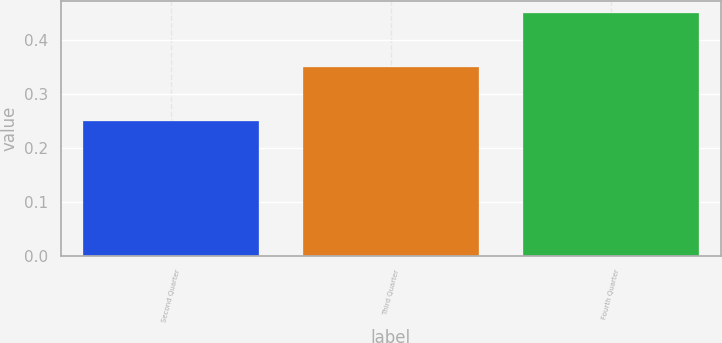<chart> <loc_0><loc_0><loc_500><loc_500><bar_chart><fcel>Second Quarter<fcel>Third Quarter<fcel>Fourth Quarter<nl><fcel>0.25<fcel>0.35<fcel>0.45<nl></chart> 